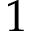<formula> <loc_0><loc_0><loc_500><loc_500>1</formula> 